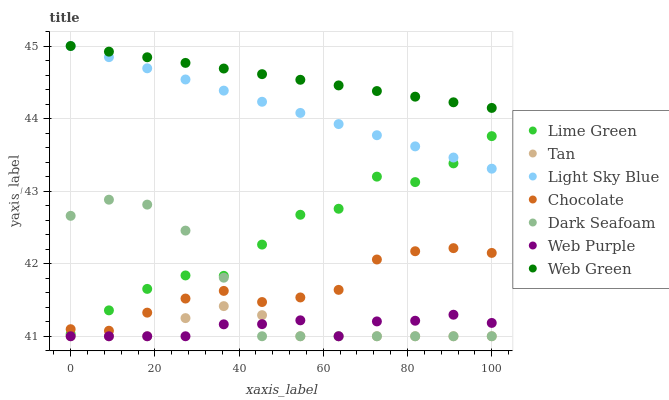Does Tan have the minimum area under the curve?
Answer yes or no. Yes. Does Web Green have the maximum area under the curve?
Answer yes or no. Yes. Does Chocolate have the minimum area under the curve?
Answer yes or no. No. Does Chocolate have the maximum area under the curve?
Answer yes or no. No. Is Light Sky Blue the smoothest?
Answer yes or no. Yes. Is Lime Green the roughest?
Answer yes or no. Yes. Is Web Green the smoothest?
Answer yes or no. No. Is Web Green the roughest?
Answer yes or no. No. Does Dark Seafoam have the lowest value?
Answer yes or no. Yes. Does Chocolate have the lowest value?
Answer yes or no. No. Does Light Sky Blue have the highest value?
Answer yes or no. Yes. Does Chocolate have the highest value?
Answer yes or no. No. Is Dark Seafoam less than Light Sky Blue?
Answer yes or no. Yes. Is Web Green greater than Lime Green?
Answer yes or no. Yes. Does Dark Seafoam intersect Web Purple?
Answer yes or no. Yes. Is Dark Seafoam less than Web Purple?
Answer yes or no. No. Is Dark Seafoam greater than Web Purple?
Answer yes or no. No. Does Dark Seafoam intersect Light Sky Blue?
Answer yes or no. No. 